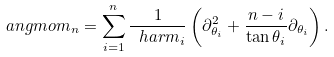Convert formula to latex. <formula><loc_0><loc_0><loc_500><loc_500>\ a n g m o m _ { n } = \sum _ { i = 1 } ^ { n } \frac { 1 } { \ h a r m _ { i } } \left ( \partial _ { \theta _ { i } } ^ { 2 } + \frac { n - i } { \tan \theta _ { i } } \partial _ { \theta _ { i } } \right ) .</formula> 